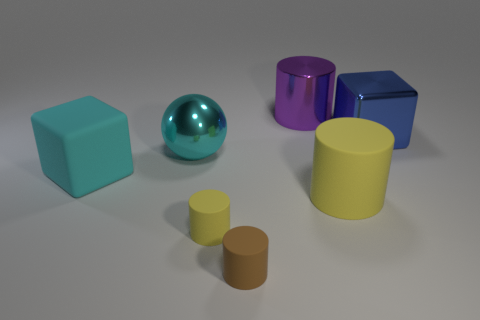Add 1 metallic objects. How many objects exist? 8 Subtract all brown cylinders. Subtract all yellow spheres. How many cylinders are left? 3 Subtract all spheres. How many objects are left? 6 Add 6 gray cubes. How many gray cubes exist? 6 Subtract 1 cyan balls. How many objects are left? 6 Subtract all purple objects. Subtract all small rubber things. How many objects are left? 4 Add 4 big purple metal objects. How many big purple metal objects are left? 5 